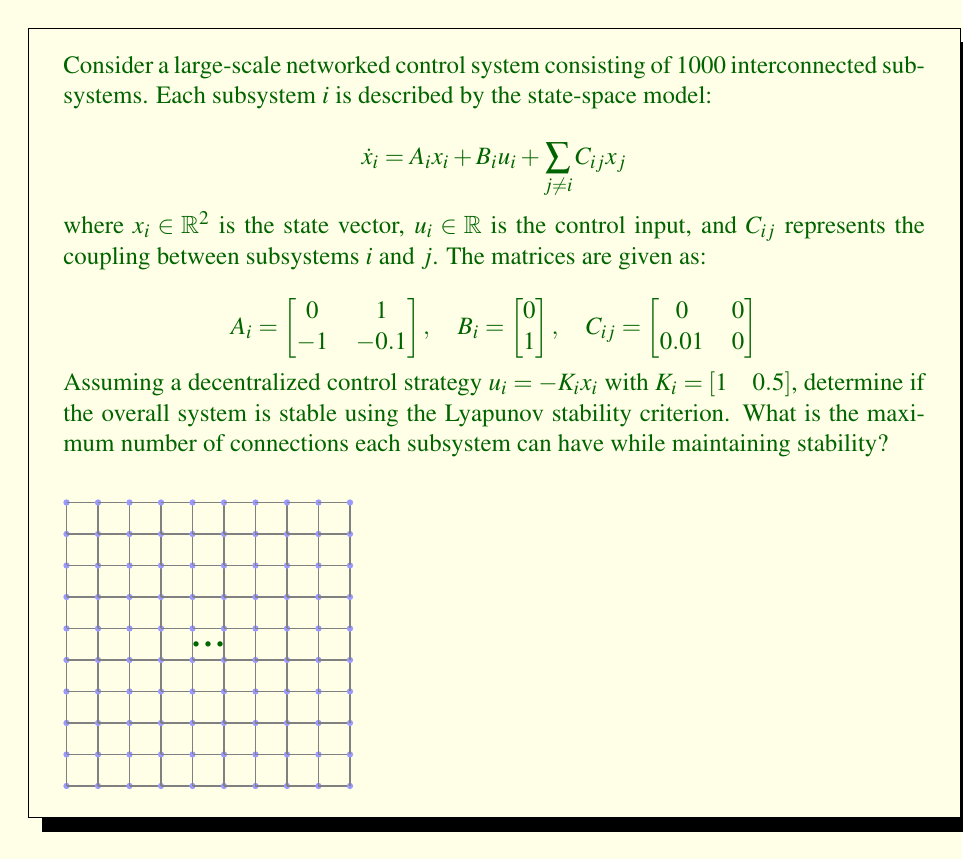Help me with this question. To analyze the stability of this large-scale networked control system, we'll use the Lyapunov stability criterion. We'll follow these steps:

1) First, we need to find the closed-loop system matrix for each subsystem:

   $$A_{cl,i} = A_i - B_iK_i = \begin{bmatrix} 0 & 1 \\ -1 & -0.1 \end{bmatrix} - \begin{bmatrix} 0 \\ 1 \end{bmatrix} [1 \quad 0.5] = \begin{bmatrix} 0 & 1 \\ -2 & -0.6 \end{bmatrix}$$

2) Now, we need to solve the Lyapunov equation for each subsystem:

   $$A_{cl,i}^TP_i + P_iA_{cl,i} = -I$$

   Where $I$ is the 2x2 identity matrix. Solving this equation gives:

   $$P_i = \begin{bmatrix} 0.7917 & 0.2083 \\ 0.2083 & 0.3750 \end{bmatrix}$$

3) The Lyapunov function for the entire system is:

   $$V(x) = \sum_{i=1}^{1000} x_i^TP_ix_i$$

4) The time derivative of V along the system trajectories is:

   $$\dot{V}(x) = \sum_{i=1}^{1000} x_i^T(A_{cl,i}^TP_i + P_iA_{cl,i})x_i + 2\sum_{i=1}^{1000}\sum_{j \neq i} x_i^TP_iC_{ij}x_j$$

5) We know that $A_{cl,i}^TP_i + P_iA_{cl,i} = -I$, so:

   $$\dot{V}(x) = -\sum_{i=1}^{1000} x_i^Tx_i + 2\sum_{i=1}^{1000}\sum_{j \neq i} x_i^TP_iC_{ij}x_j$$

6) For stability, we need $\dot{V}(x) < 0$ for all $x \neq 0$. This will be true if:

   $$2\sum_{i=1}^{1000}\sum_{j \neq i} x_i^TP_iC_{ij}x_j < \sum_{i=1}^{1000} x_i^Tx_i$$

7) Using the Cauchy-Schwarz inequality, we can bound the left side:

   $$2\sum_{i=1}^{1000}\sum_{j \neq i} x_i^TP_iC_{ij}x_j \leq 2\sum_{i=1}^{1000}\sum_{j \neq i} \|P_iC_{ij}\| \|x_i\| \|x_j\|$$

8) Calculate $\|P_iC_{ij}\|$:

   $$\|P_iC_{ij}\| = \left\|\begin{bmatrix} 0.7917 & 0.2083 \\ 0.2083 & 0.3750 \end{bmatrix}\begin{bmatrix} 0 & 0 \\ 0.01 & 0 \end{bmatrix}\right\| \approx 0.00375$$

9) For stability, we need:

   $$2 \cdot 0.00375 \cdot k \cdot \sum_{i=1}^{1000} \|x_i\|^2 < \sum_{i=1}^{1000} x_i^Tx_i$$

   Where $k$ is the number of connections per subsystem.

10) This inequality holds if:

    $$2 \cdot 0.00375 \cdot k < 1$$

    $$k < \frac{1}{2 \cdot 0.00375} \approx 133.33$$

Therefore, each subsystem can have at most 133 connections while maintaining stability.
Answer: 133 connections per subsystem 